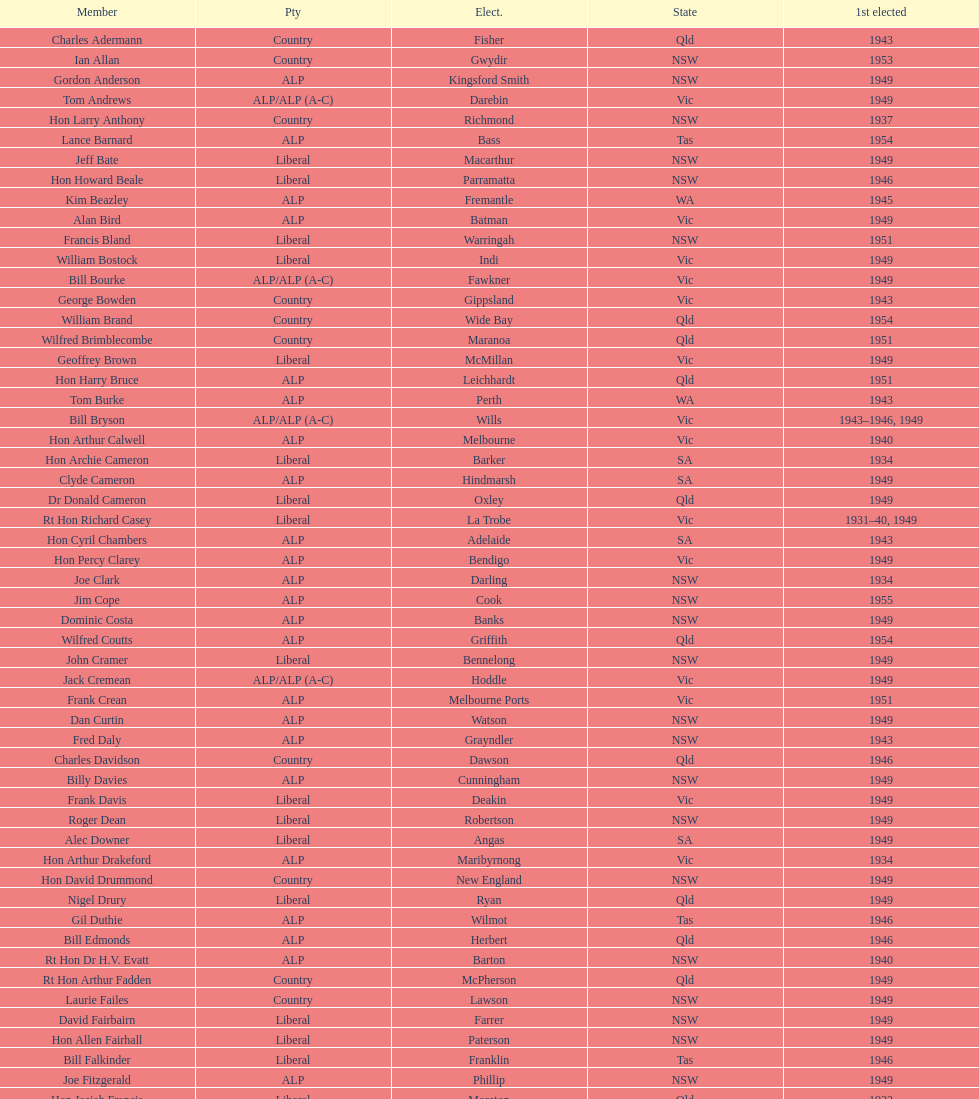I'm looking to parse the entire table for insights. Could you assist me with that? {'header': ['Member', 'Pty', 'Elect.', 'State', '1st elected'], 'rows': [['Charles Adermann', 'Country', 'Fisher', 'Qld', '1943'], ['Ian Allan', 'Country', 'Gwydir', 'NSW', '1953'], ['Gordon Anderson', 'ALP', 'Kingsford Smith', 'NSW', '1949'], ['Tom Andrews', 'ALP/ALP (A-C)', 'Darebin', 'Vic', '1949'], ['Hon Larry Anthony', 'Country', 'Richmond', 'NSW', '1937'], ['Lance Barnard', 'ALP', 'Bass', 'Tas', '1954'], ['Jeff Bate', 'Liberal', 'Macarthur', 'NSW', '1949'], ['Hon Howard Beale', 'Liberal', 'Parramatta', 'NSW', '1946'], ['Kim Beazley', 'ALP', 'Fremantle', 'WA', '1945'], ['Alan Bird', 'ALP', 'Batman', 'Vic', '1949'], ['Francis Bland', 'Liberal', 'Warringah', 'NSW', '1951'], ['William Bostock', 'Liberal', 'Indi', 'Vic', '1949'], ['Bill Bourke', 'ALP/ALP (A-C)', 'Fawkner', 'Vic', '1949'], ['George Bowden', 'Country', 'Gippsland', 'Vic', '1943'], ['William Brand', 'Country', 'Wide Bay', 'Qld', '1954'], ['Wilfred Brimblecombe', 'Country', 'Maranoa', 'Qld', '1951'], ['Geoffrey Brown', 'Liberal', 'McMillan', 'Vic', '1949'], ['Hon Harry Bruce', 'ALP', 'Leichhardt', 'Qld', '1951'], ['Tom Burke', 'ALP', 'Perth', 'WA', '1943'], ['Bill Bryson', 'ALP/ALP (A-C)', 'Wills', 'Vic', '1943–1946, 1949'], ['Hon Arthur Calwell', 'ALP', 'Melbourne', 'Vic', '1940'], ['Hon Archie Cameron', 'Liberal', 'Barker', 'SA', '1934'], ['Clyde Cameron', 'ALP', 'Hindmarsh', 'SA', '1949'], ['Dr Donald Cameron', 'Liberal', 'Oxley', 'Qld', '1949'], ['Rt Hon Richard Casey', 'Liberal', 'La Trobe', 'Vic', '1931–40, 1949'], ['Hon Cyril Chambers', 'ALP', 'Adelaide', 'SA', '1943'], ['Hon Percy Clarey', 'ALP', 'Bendigo', 'Vic', '1949'], ['Joe Clark', 'ALP', 'Darling', 'NSW', '1934'], ['Jim Cope', 'ALP', 'Cook', 'NSW', '1955'], ['Dominic Costa', 'ALP', 'Banks', 'NSW', '1949'], ['Wilfred Coutts', 'ALP', 'Griffith', 'Qld', '1954'], ['John Cramer', 'Liberal', 'Bennelong', 'NSW', '1949'], ['Jack Cremean', 'ALP/ALP (A-C)', 'Hoddle', 'Vic', '1949'], ['Frank Crean', 'ALP', 'Melbourne Ports', 'Vic', '1951'], ['Dan Curtin', 'ALP', 'Watson', 'NSW', '1949'], ['Fred Daly', 'ALP', 'Grayndler', 'NSW', '1943'], ['Charles Davidson', 'Country', 'Dawson', 'Qld', '1946'], ['Billy Davies', 'ALP', 'Cunningham', 'NSW', '1949'], ['Frank Davis', 'Liberal', 'Deakin', 'Vic', '1949'], ['Roger Dean', 'Liberal', 'Robertson', 'NSW', '1949'], ['Alec Downer', 'Liberal', 'Angas', 'SA', '1949'], ['Hon Arthur Drakeford', 'ALP', 'Maribyrnong', 'Vic', '1934'], ['Hon David Drummond', 'Country', 'New England', 'NSW', '1949'], ['Nigel Drury', 'Liberal', 'Ryan', 'Qld', '1949'], ['Gil Duthie', 'ALP', 'Wilmot', 'Tas', '1946'], ['Bill Edmonds', 'ALP', 'Herbert', 'Qld', '1946'], ['Rt Hon Dr H.V. Evatt', 'ALP', 'Barton', 'NSW', '1940'], ['Rt Hon Arthur Fadden', 'Country', 'McPherson', 'Qld', '1949'], ['Laurie Failes', 'Country', 'Lawson', 'NSW', '1949'], ['David Fairbairn', 'Liberal', 'Farrer', 'NSW', '1949'], ['Hon Allen Fairhall', 'Liberal', 'Paterson', 'NSW', '1949'], ['Bill Falkinder', 'Liberal', 'Franklin', 'Tas', '1946'], ['Joe Fitzgerald', 'ALP', 'Phillip', 'NSW', '1949'], ['Hon Josiah Francis', 'Liberal', 'Moreton', 'Qld', '1922'], ['Allan Fraser', 'ALP', 'Eden-Monaro', 'NSW', '1943'], ['Jim Fraser', 'ALP', 'Australian Capital Territory', 'ACT', '1951'], ['Gordon Freeth', 'Liberal', 'Forrest', 'WA', '1949'], ['Arthur Fuller', 'Country', 'Hume', 'NSW', '1943–49, 1951'], ['Pat Galvin', 'ALP', 'Kingston', 'SA', '1951'], ['Arthur Greenup', 'ALP', 'Dalley', 'NSW', '1953'], ['Charles Griffiths', 'ALP', 'Shortland', 'NSW', '1949'], ['Jo Gullett', 'Liberal', 'Henty', 'Vic', '1946'], ['Len Hamilton', 'Country', 'Canning', 'WA', '1946'], ['Rt Hon Eric Harrison', 'Liberal', 'Wentworth', 'NSW', '1931'], ['Jim Harrison', 'ALP', 'Blaxland', 'NSW', '1949'], ['Hon Paul Hasluck', 'Liberal', 'Curtin', 'WA', '1949'], ['Hon William Haworth', 'Liberal', 'Isaacs', 'Vic', '1949'], ['Leslie Haylen', 'ALP', 'Parkes', 'NSW', '1943'], ['Rt Hon Harold Holt', 'Liberal', 'Higgins', 'Vic', '1935'], ['John Howse', 'Liberal', 'Calare', 'NSW', '1946'], ['Alan Hulme', 'Liberal', 'Petrie', 'Qld', '1949'], ['William Jack', 'Liberal', 'North Sydney', 'NSW', '1949'], ['Rowley James', 'ALP', 'Hunter', 'NSW', '1928'], ['Hon Herbert Johnson', 'ALP', 'Kalgoorlie', 'WA', '1940'], ['Bob Joshua', 'ALP/ALP (A-C)', 'Ballaarat', 'ALP', '1951'], ['Percy Joske', 'Liberal', 'Balaclava', 'Vic', '1951'], ['Hon Wilfrid Kent Hughes', 'Liberal', 'Chisholm', 'Vic', '1949'], ['Stan Keon', 'ALP/ALP (A-C)', 'Yarra', 'Vic', '1949'], ['William Lawrence', 'Liberal', 'Wimmera', 'Vic', '1949'], ['Hon George Lawson', 'ALP', 'Brisbane', 'Qld', '1931'], ['Nelson Lemmon', 'ALP', 'St George', 'NSW', '1943–49, 1954'], ['Hugh Leslie', 'Liberal', 'Moore', 'Country', '1949'], ['Robert Lindsay', 'Liberal', 'Flinders', 'Vic', '1954'], ['Tony Luchetti', 'ALP', 'Macquarie', 'NSW', '1951'], ['Aubrey Luck', 'Liberal', 'Darwin', 'Tas', '1951'], ['Philip Lucock', 'Country', 'Lyne', 'NSW', '1953'], ['Dan Mackinnon', 'Liberal', 'Corangamite', 'Vic', '1949–51, 1953'], ['Hon Norman Makin', 'ALP', 'Sturt', 'SA', '1919–46, 1954'], ['Hon Philip McBride', 'Liberal', 'Wakefield', 'SA', '1931–37, 1937–43 (S), 1946'], ['Malcolm McColm', 'Liberal', 'Bowman', 'Qld', '1949'], ['Rt Hon John McEwen', 'Country', 'Murray', 'Vic', '1934'], ['John McLeay', 'Liberal', 'Boothby', 'SA', '1949'], ['Don McLeod', 'Liberal', 'Wannon', 'ALP', '1940–49, 1951'], ['Hon William McMahon', 'Liberal', 'Lowe', 'NSW', '1949'], ['Rt Hon Robert Menzies', 'Liberal', 'Kooyong', 'Vic', '1934'], ['Dan Minogue', 'ALP', 'West Sydney', 'NSW', '1949'], ['Charles Morgan', 'ALP', 'Reid', 'NSW', '1940–46, 1949'], ['Jack Mullens', 'ALP/ALP (A-C)', 'Gellibrand', 'Vic', '1949'], ['Jock Nelson', 'ALP', 'Northern Territory', 'NT', '1949'], ["William O'Connor", 'ALP', 'Martin', 'NSW', '1946'], ['Hubert Opperman', 'Liberal', 'Corio', 'Vic', '1949'], ['Hon Frederick Osborne', 'Liberal', 'Evans', 'NSW', '1949'], ['Rt Hon Sir Earle Page', 'Country', 'Cowper', 'NSW', '1919'], ['Henry Pearce', 'Liberal', 'Capricornia', 'Qld', '1949'], ['Ted Peters', 'ALP', 'Burke', 'Vic', '1949'], ['Hon Reg Pollard', 'ALP', 'Lalor', 'Vic', '1937'], ['Hon Bill Riordan', 'ALP', 'Kennedy', 'Qld', '1936'], ['Hugh Roberton', 'Country', 'Riverina', 'NSW', '1949'], ['Edgar Russell', 'ALP', 'Grey', 'SA', '1943'], ['Tom Sheehan', 'ALP', 'Cook', 'NSW', '1937'], ['Frank Stewart', 'ALP', 'Lang', 'NSW', '1953'], ['Reginald Swartz', 'Liberal', 'Darling Downs', 'Qld', '1949'], ['Albert Thompson', 'ALP', 'Port Adelaide', 'SA', '1946'], ['Frank Timson', 'Liberal', 'Higinbotham', 'Vic', '1949'], ['Hon Athol Townley', 'Liberal', 'Denison', 'Tas', '1949'], ['Winton Turnbull', 'Country', 'Mallee', 'Vic', '1946'], ['Harry Turner', 'Liberal', 'Bradfield', 'NSW', '1952'], ['Hon Eddie Ward', 'ALP', 'East Sydney', 'NSW', '1931, 1932'], ['David Oliver Watkins', 'ALP', 'Newcastle', 'NSW', '1935'], ['Harry Webb', 'ALP', 'Swan', 'WA', '1954'], ['William Wentworth', 'Liberal', 'Mackellar', 'NSW', '1949'], ['Roy Wheeler', 'Liberal', 'Mitchell', 'NSW', '1949'], ['Gough Whitlam', 'ALP', 'Werriwa', 'NSW', '1952'], ['Bruce Wight', 'Liberal', 'Lilley', 'Qld', '1949']]} Who was the first member to be elected? Charles Adermann. 